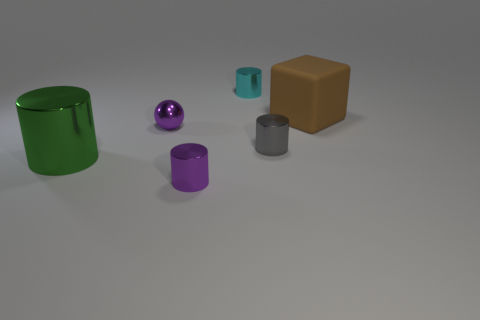Are there any other things that are made of the same material as the brown block?
Provide a short and direct response. No. What color is the large object that is the same material as the small cyan object?
Keep it short and to the point. Green. Is the number of tiny things in front of the tiny purple metal ball less than the number of cyan matte objects?
Make the answer very short. No. There is a tiny purple thing that is made of the same material as the purple cylinder; what shape is it?
Provide a succinct answer. Sphere. What number of matte things are either green cylinders or big green spheres?
Your response must be concise. 0. Is the number of cubes in front of the matte thing the same as the number of tiny cylinders?
Your answer should be compact. No. Do the tiny metallic thing to the left of the tiny purple shiny cylinder and the large cylinder have the same color?
Ensure brevity in your answer.  No. There is a object that is right of the cyan metallic object and behind the gray metal object; what is it made of?
Your answer should be very brief. Rubber. There is a big thing that is on the right side of the large green cylinder; is there a cube behind it?
Offer a very short reply. No. Is the material of the big green object the same as the purple sphere?
Offer a very short reply. Yes. 